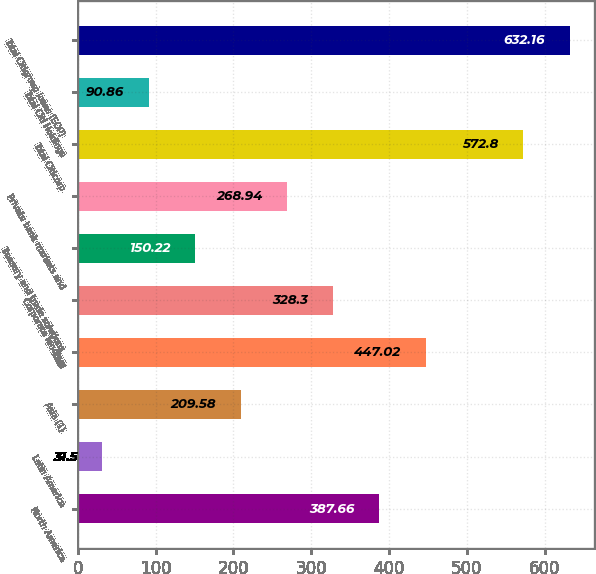<chart> <loc_0><loc_0><loc_500><loc_500><bar_chart><fcel>North America<fcel>Latin America<fcel>Asia (1)<fcel>Total<fcel>Corporate lending<fcel>Treasury and trade solutions<fcel>Private bank markets and<fcel>Total Citicorp<fcel>Total Citi Holdings<fcel>Total Citigroup loans (EOP)<nl><fcel>387.66<fcel>31.5<fcel>209.58<fcel>447.02<fcel>328.3<fcel>150.22<fcel>268.94<fcel>572.8<fcel>90.86<fcel>632.16<nl></chart> 